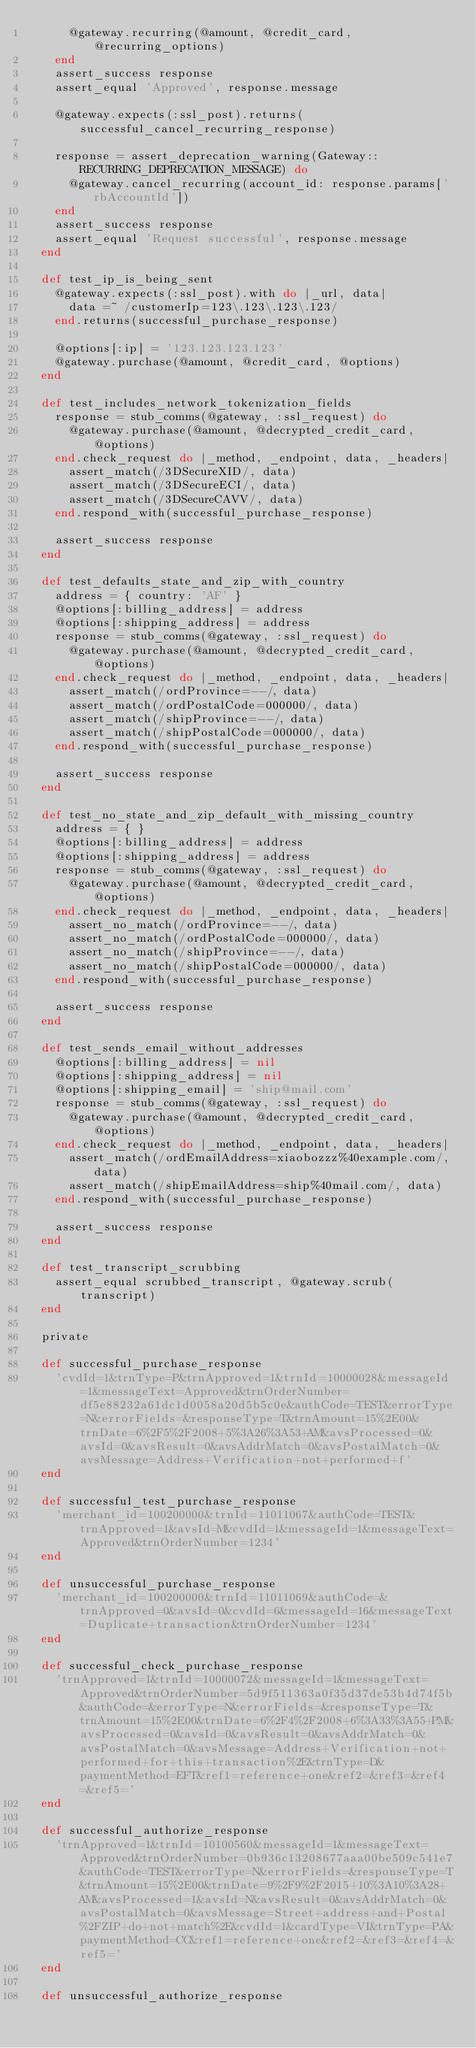Convert code to text. <code><loc_0><loc_0><loc_500><loc_500><_Ruby_>      @gateway.recurring(@amount, @credit_card, @recurring_options)
    end
    assert_success response
    assert_equal 'Approved', response.message

    @gateway.expects(:ssl_post).returns(successful_cancel_recurring_response)

    response = assert_deprecation_warning(Gateway::RECURRING_DEPRECATION_MESSAGE) do
      @gateway.cancel_recurring(account_id: response.params['rbAccountId'])
    end
    assert_success response
    assert_equal 'Request successful', response.message
  end

  def test_ip_is_being_sent
    @gateway.expects(:ssl_post).with do |_url, data|
      data =~ /customerIp=123\.123\.123\.123/
    end.returns(successful_purchase_response)

    @options[:ip] = '123.123.123.123'
    @gateway.purchase(@amount, @credit_card, @options)
  end

  def test_includes_network_tokenization_fields
    response = stub_comms(@gateway, :ssl_request) do
      @gateway.purchase(@amount, @decrypted_credit_card, @options)
    end.check_request do |_method, _endpoint, data, _headers|
      assert_match(/3DSecureXID/, data)
      assert_match(/3DSecureECI/, data)
      assert_match(/3DSecureCAVV/, data)
    end.respond_with(successful_purchase_response)

    assert_success response
  end

  def test_defaults_state_and_zip_with_country
    address = { country: 'AF' }
    @options[:billing_address] = address
    @options[:shipping_address] = address
    response = stub_comms(@gateway, :ssl_request) do
      @gateway.purchase(@amount, @decrypted_credit_card, @options)
    end.check_request do |_method, _endpoint, data, _headers|
      assert_match(/ordProvince=--/, data)
      assert_match(/ordPostalCode=000000/, data)
      assert_match(/shipProvince=--/, data)
      assert_match(/shipPostalCode=000000/, data)
    end.respond_with(successful_purchase_response)

    assert_success response
  end

  def test_no_state_and_zip_default_with_missing_country
    address = { }
    @options[:billing_address] = address
    @options[:shipping_address] = address
    response = stub_comms(@gateway, :ssl_request) do
      @gateway.purchase(@amount, @decrypted_credit_card, @options)
    end.check_request do |_method, _endpoint, data, _headers|
      assert_no_match(/ordProvince=--/, data)
      assert_no_match(/ordPostalCode=000000/, data)
      assert_no_match(/shipProvince=--/, data)
      assert_no_match(/shipPostalCode=000000/, data)
    end.respond_with(successful_purchase_response)

    assert_success response
  end

  def test_sends_email_without_addresses
    @options[:billing_address] = nil
    @options[:shipping_address] = nil
    @options[:shipping_email] = 'ship@mail.com'
    response = stub_comms(@gateway, :ssl_request) do
      @gateway.purchase(@amount, @decrypted_credit_card, @options)
    end.check_request do |_method, _endpoint, data, _headers|
      assert_match(/ordEmailAddress=xiaobozzz%40example.com/, data)
      assert_match(/shipEmailAddress=ship%40mail.com/, data)
    end.respond_with(successful_purchase_response)

    assert_success response
  end

  def test_transcript_scrubbing
    assert_equal scrubbed_transcript, @gateway.scrub(transcript)
  end

  private

  def successful_purchase_response
    'cvdId=1&trnType=P&trnApproved=1&trnId=10000028&messageId=1&messageText=Approved&trnOrderNumber=df5e88232a61dc1d0058a20d5b5c0e&authCode=TEST&errorType=N&errorFields=&responseType=T&trnAmount=15%2E00&trnDate=6%2F5%2F2008+5%3A26%3A53+AM&avsProcessed=0&avsId=0&avsResult=0&avsAddrMatch=0&avsPostalMatch=0&avsMessage=Address+Verification+not+performed+f'
  end

  def successful_test_purchase_response
    'merchant_id=100200000&trnId=11011067&authCode=TEST&trnApproved=1&avsId=M&cvdId=1&messageId=1&messageText=Approved&trnOrderNumber=1234'
  end

  def unsuccessful_purchase_response
    'merchant_id=100200000&trnId=11011069&authCode=&trnApproved=0&avsId=0&cvdId=6&messageId=16&messageText=Duplicate+transaction&trnOrderNumber=1234'
  end

  def successful_check_purchase_response
    'trnApproved=1&trnId=10000072&messageId=1&messageText=Approved&trnOrderNumber=5d9f511363a0f35d37de53b4d74f5b&authCode=&errorType=N&errorFields=&responseType=T&trnAmount=15%2E00&trnDate=6%2F4%2F2008+6%3A33%3A55+PM&avsProcessed=0&avsId=0&avsResult=0&avsAddrMatch=0&avsPostalMatch=0&avsMessage=Address+Verification+not+performed+for+this+transaction%2E&trnType=D&paymentMethod=EFT&ref1=reference+one&ref2=&ref3=&ref4=&ref5='
  end

  def successful_authorize_response
    'trnApproved=1&trnId=10100560&messageId=1&messageText=Approved&trnOrderNumber=0b936c13208677aaa00be509c541e7&authCode=TEST&errorType=N&errorFields=&responseType=T&trnAmount=15%2E00&trnDate=9%2F9%2F2015+10%3A10%3A28+AM&avsProcessed=1&avsId=N&avsResult=0&avsAddrMatch=0&avsPostalMatch=0&avsMessage=Street+address+and+Postal%2FZIP+do+not+match%2E&cvdId=1&cardType=VI&trnType=PA&paymentMethod=CC&ref1=reference+one&ref2=&ref3=&ref4=&ref5='
  end

  def unsuccessful_authorize_response</code> 